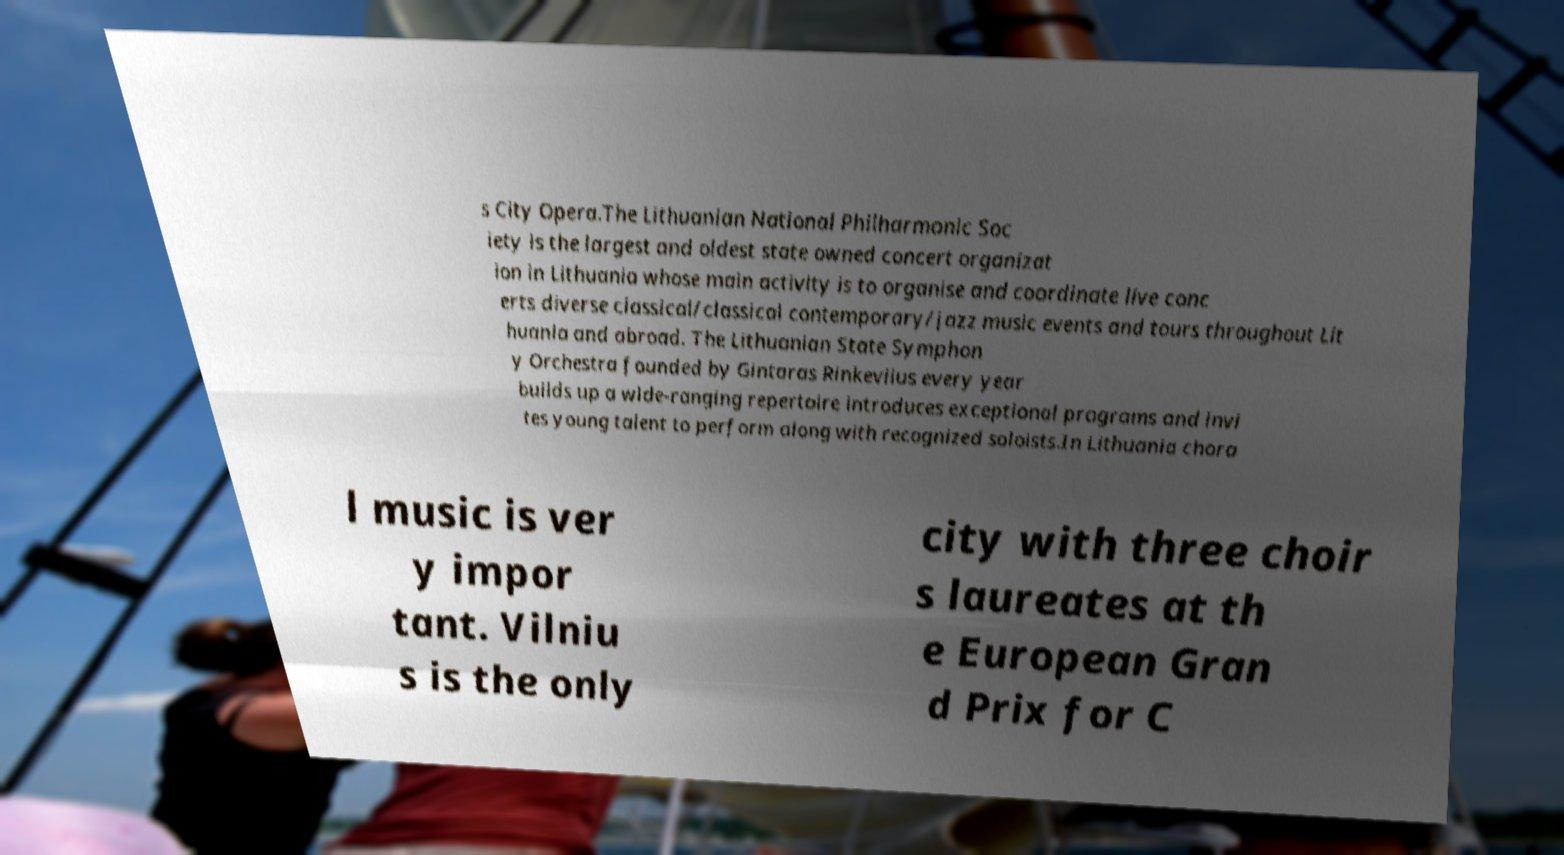There's text embedded in this image that I need extracted. Can you transcribe it verbatim? s City Opera.The Lithuanian National Philharmonic Soc iety is the largest and oldest state owned concert organizat ion in Lithuania whose main activity is to organise and coordinate live conc erts diverse classical/classical contemporary/jazz music events and tours throughout Lit huania and abroad. The Lithuanian State Symphon y Orchestra founded by Gintaras Rinkeviius every year builds up a wide-ranging repertoire introduces exceptional programs and invi tes young talent to perform along with recognized soloists.In Lithuania chora l music is ver y impor tant. Vilniu s is the only city with three choir s laureates at th e European Gran d Prix for C 